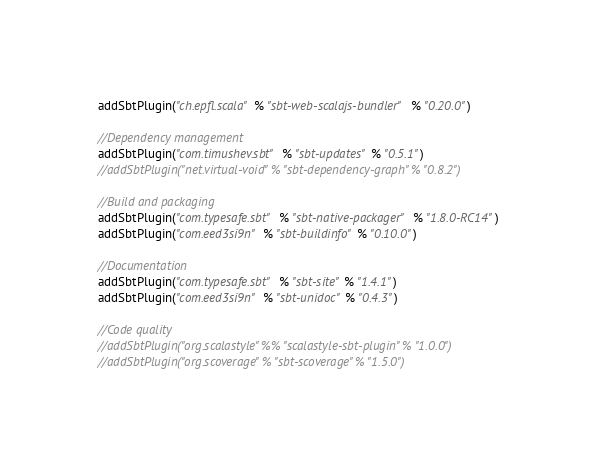<code> <loc_0><loc_0><loc_500><loc_500><_Scala_>addSbtPlugin("ch.epfl.scala" % "sbt-web-scalajs-bundler" % "0.20.0")

//Dependency management
addSbtPlugin("com.timushev.sbt" % "sbt-updates" % "0.5.1")
//addSbtPlugin("net.virtual-void" % "sbt-dependency-graph" % "0.8.2")

//Build and packaging
addSbtPlugin("com.typesafe.sbt" % "sbt-native-packager" % "1.8.0-RC14")
addSbtPlugin("com.eed3si9n" % "sbt-buildinfo" % "0.10.0")

//Documentation
addSbtPlugin("com.typesafe.sbt" % "sbt-site" % "1.4.1")
addSbtPlugin("com.eed3si9n" % "sbt-unidoc" % "0.4.3")

//Code quality
//addSbtPlugin("org.scalastyle" %% "scalastyle-sbt-plugin" % "1.0.0")
//addSbtPlugin("org.scoverage" % "sbt-scoverage" % "1.5.0")

</code> 